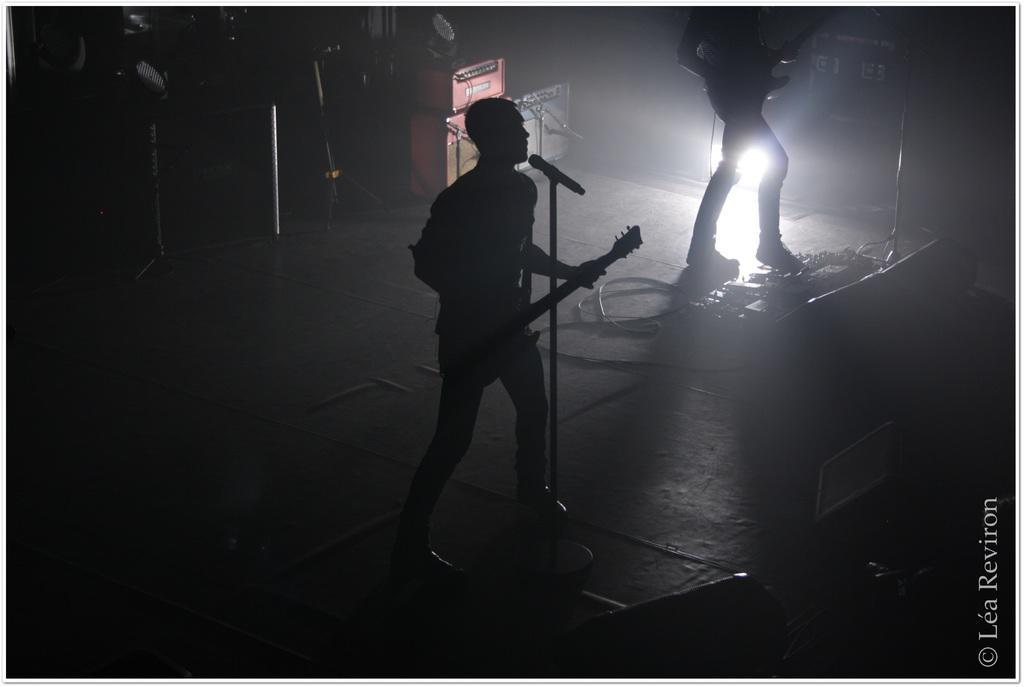Please provide a concise description of this image. There is a boy in the center of the image by holding a guitar in his hands and there is a mic in front of him. There is another person in the image and there are some objects in the dark. 